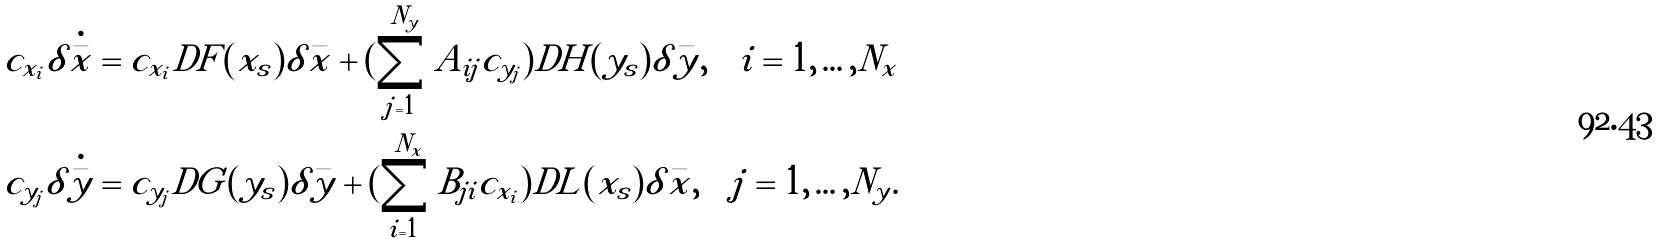<formula> <loc_0><loc_0><loc_500><loc_500>c _ { x _ { i } } { \delta \dot { \bar { x } } } = c _ { x _ { i } } D F ( x _ { s } ) \delta \bar { x } + ( \sum _ { j = 1 } ^ { N _ { y } } A _ { i j } c _ { y _ { j } } ) D H ( y _ { s } ) \delta \bar { y } , \quad i = 1 , \dots , N _ { x } \\ c _ { y _ { j } } { \delta \dot { \bar { y } } } = c _ { y _ { j } } D G ( y _ { s } ) \delta \bar { y } + ( \sum _ { i = 1 } ^ { N _ { x } } B _ { j i } c _ { x _ { i } } ) D L ( x _ { s } ) \delta \bar { x } , \quad j = 1 , \dots , N _ { y } .</formula> 